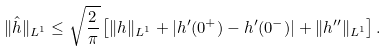<formula> <loc_0><loc_0><loc_500><loc_500>\| \hat { h } \| _ { L ^ { 1 } } \leq \sqrt { \frac { 2 } { \pi } } \left [ \| h \| _ { L ^ { 1 } } + | h ^ { \prime } ( 0 ^ { + } ) - h ^ { \prime } ( 0 ^ { - } ) | + \| h ^ { \prime \prime } \| _ { L ^ { 1 } } \right ] .</formula> 